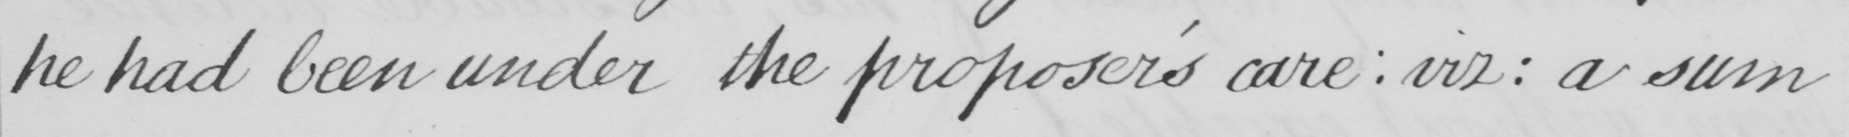Please transcribe the handwritten text in this image. he had been under the proposer ' s care :  viz :  a sum 